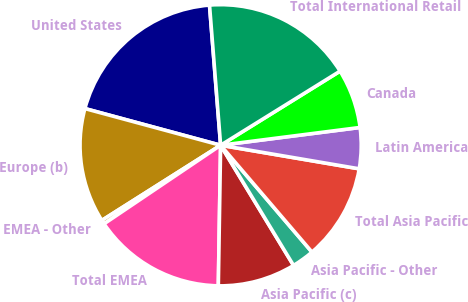Convert chart. <chart><loc_0><loc_0><loc_500><loc_500><pie_chart><fcel>United States<fcel>Europe (b)<fcel>EMEA - Other<fcel>Total EMEA<fcel>Asia Pacific (c)<fcel>Asia Pacific - Other<fcel>Total Asia Pacific<fcel>Latin America<fcel>Canada<fcel>Total International Retail<nl><fcel>19.54%<fcel>13.18%<fcel>0.46%<fcel>15.3%<fcel>8.94%<fcel>2.58%<fcel>11.06%<fcel>4.7%<fcel>6.82%<fcel>17.42%<nl></chart> 